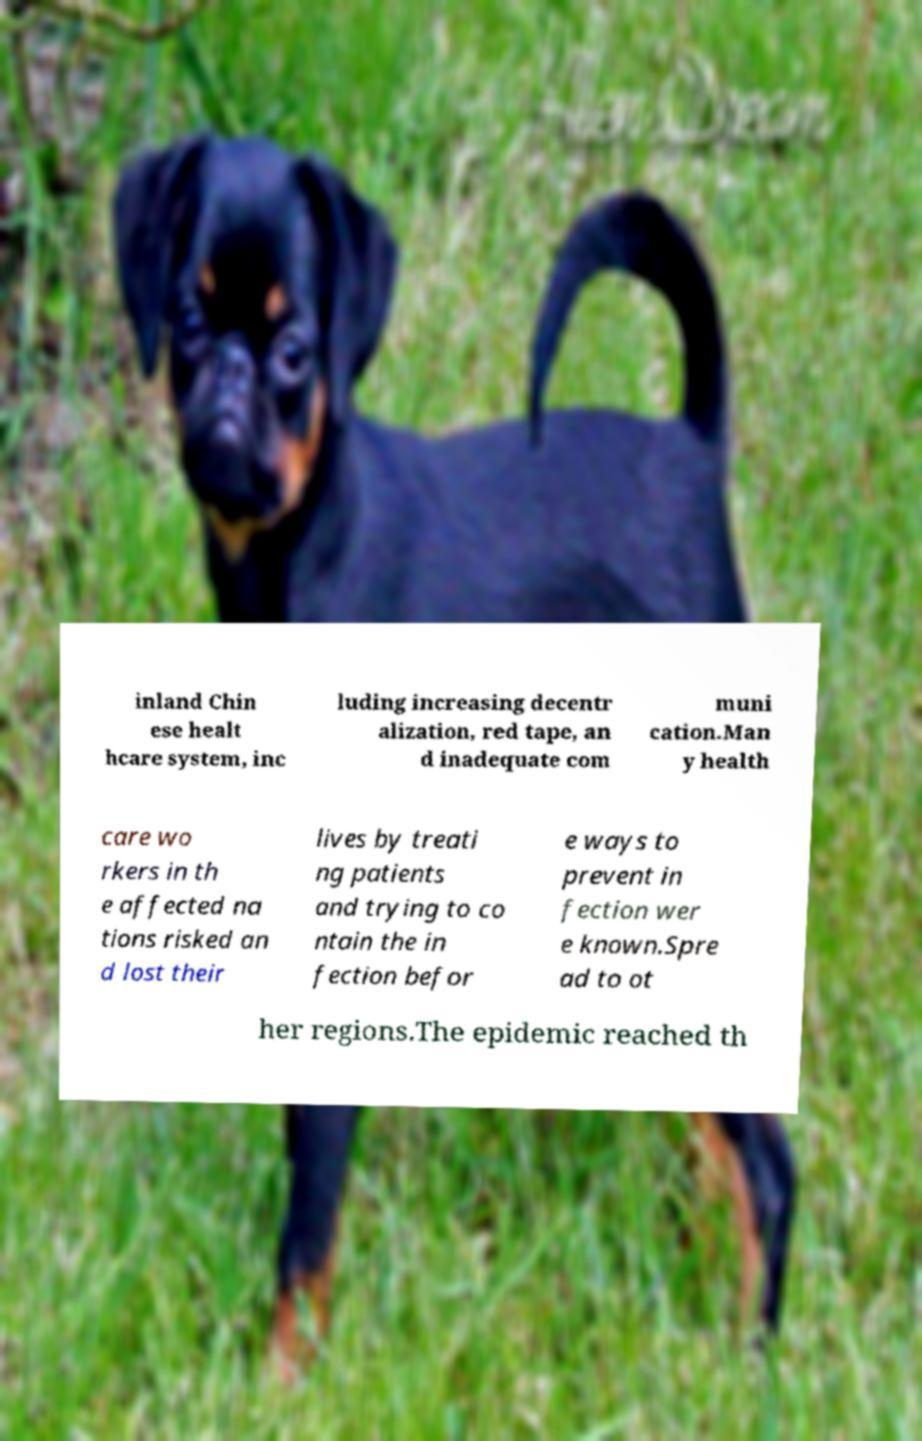Can you accurately transcribe the text from the provided image for me? inland Chin ese healt hcare system, inc luding increasing decentr alization, red tape, an d inadequate com muni cation.Man y health care wo rkers in th e affected na tions risked an d lost their lives by treati ng patients and trying to co ntain the in fection befor e ways to prevent in fection wer e known.Spre ad to ot her regions.The epidemic reached th 